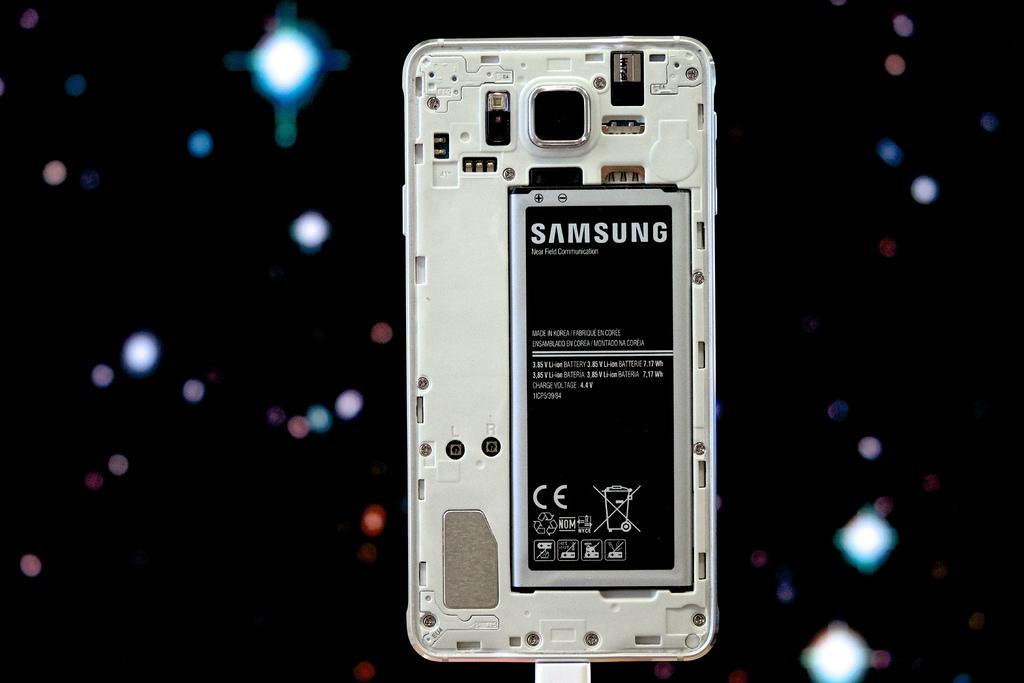Provide a one-sentence caption for the provided image. A Samsung battery in a mobile phone with the phone's back cover removed. 